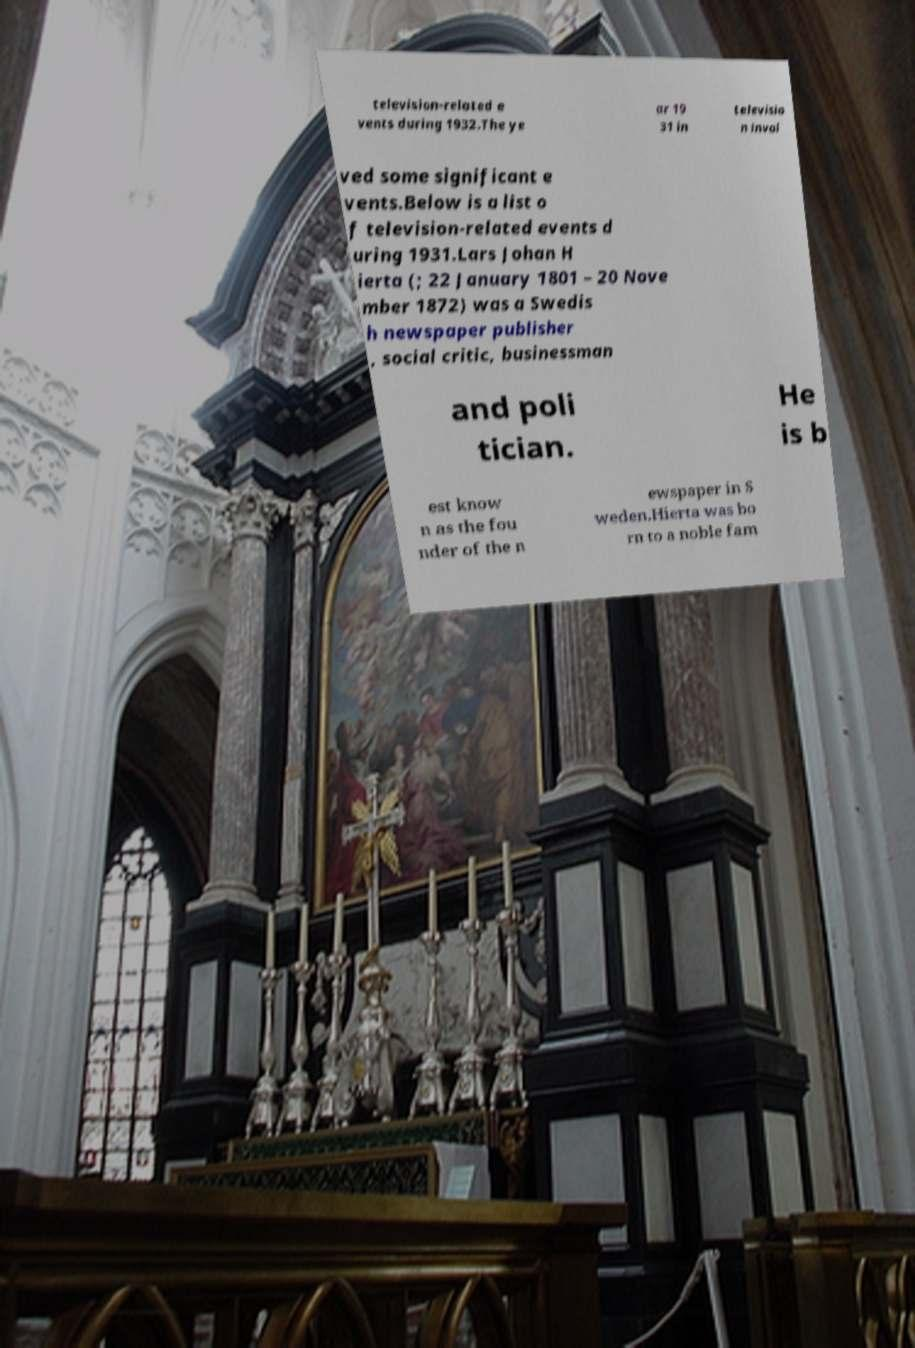Could you extract and type out the text from this image? television-related e vents during 1932.The ye ar 19 31 in televisio n invol ved some significant e vents.Below is a list o f television-related events d uring 1931.Lars Johan H ierta (; 22 January 1801 – 20 Nove mber 1872) was a Swedis h newspaper publisher , social critic, businessman and poli tician. He is b est know n as the fou nder of the n ewspaper in S weden.Hierta was bo rn to a noble fam 